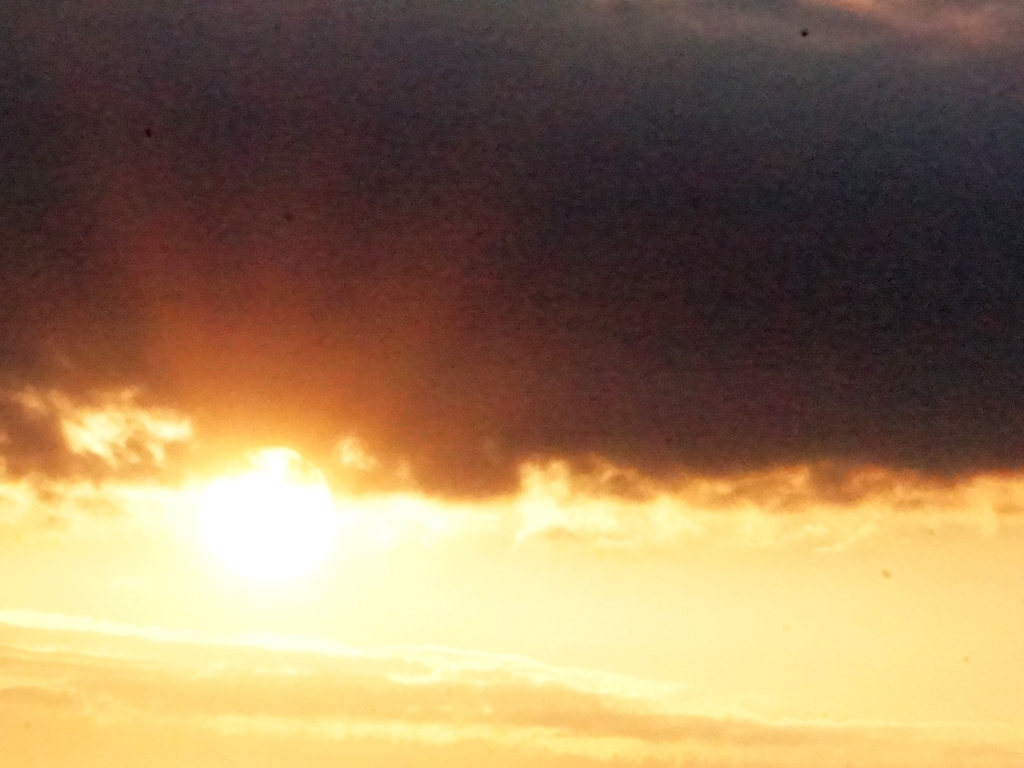Does this image have low clarity? The image appears to be somewhat unclear and grainy, which may be due to several factors such as the lighting conditions, camera quality, or the presence of fine particles in the air catching the light. It captures the sun peeking through what seems to be a haze, contributing to a somewhat ethereal and soft-focus effect on the image. 